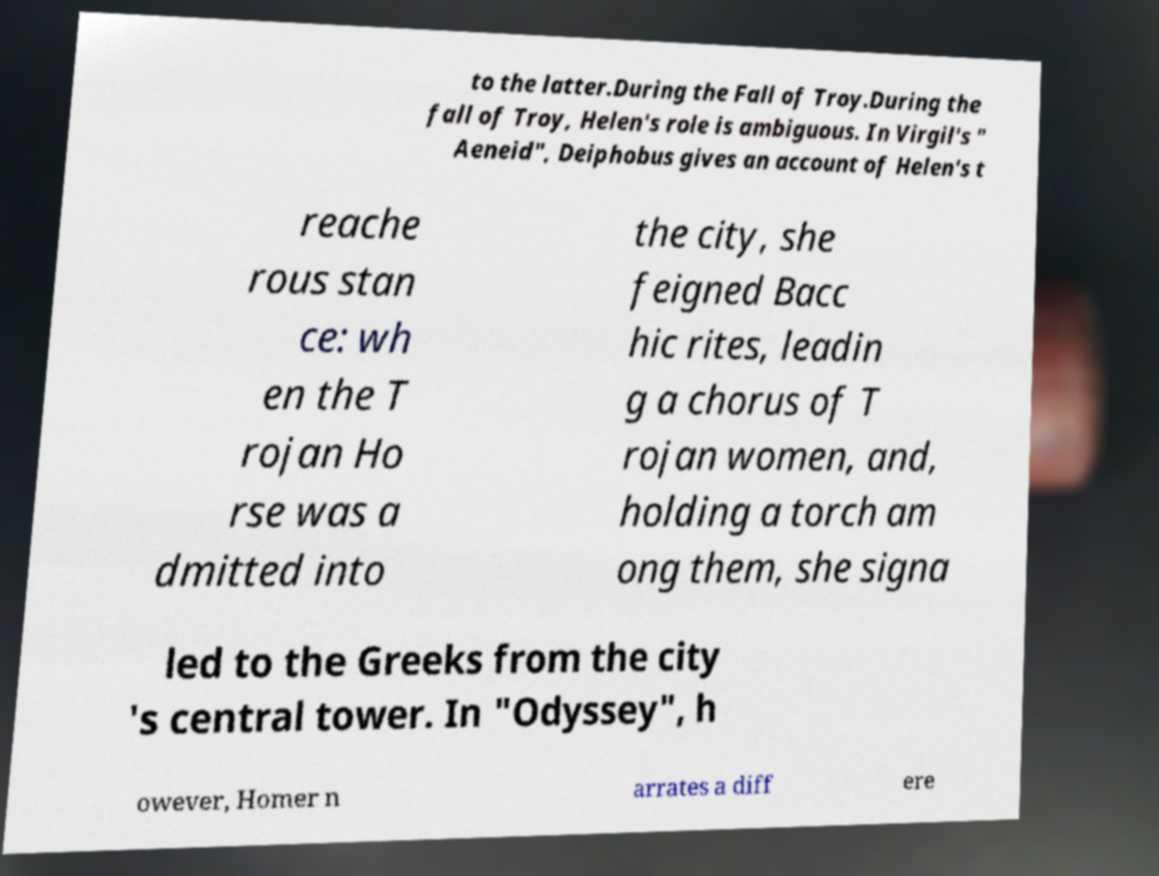There's text embedded in this image that I need extracted. Can you transcribe it verbatim? to the latter.During the Fall of Troy.During the fall of Troy, Helen's role is ambiguous. In Virgil's " Aeneid", Deiphobus gives an account of Helen's t reache rous stan ce: wh en the T rojan Ho rse was a dmitted into the city, she feigned Bacc hic rites, leadin g a chorus of T rojan women, and, holding a torch am ong them, she signa led to the Greeks from the city 's central tower. In "Odyssey", h owever, Homer n arrates a diff ere 